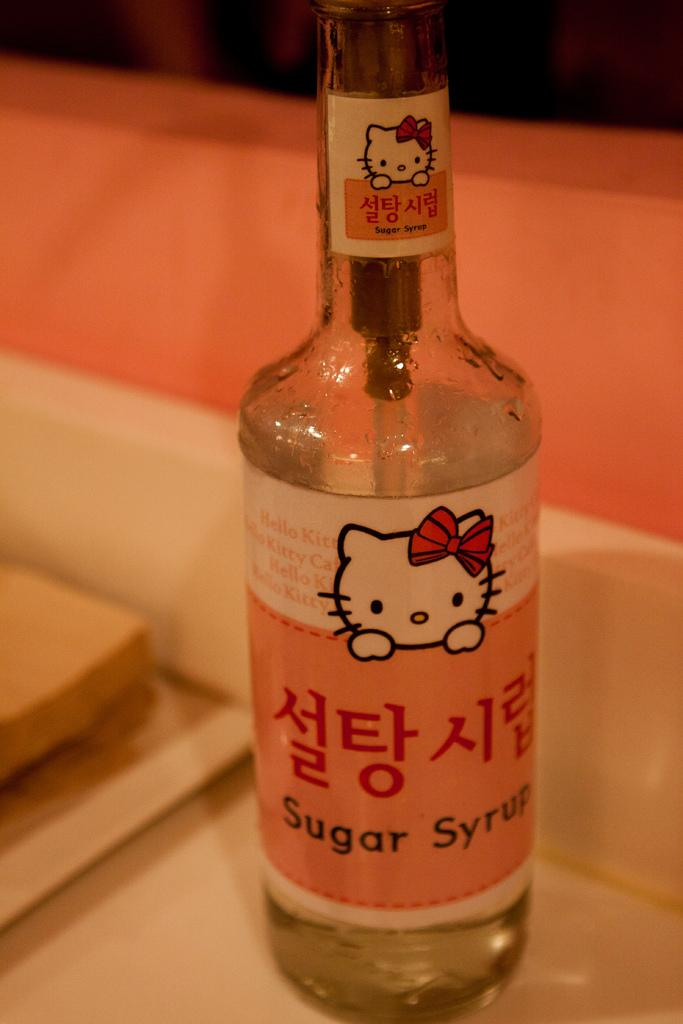What object can be seen in the image that is used for holding liquids? There is a bottle in the image that is used for holding liquids. What color is the bottle in the image? The bottle is orange in color. What piece of furniture is present in the image? There is a table in the image. What color is the table in the image? The table is white in color. What type of comfort can be found in the crib in the image? There is no crib present in the image, so it is not possible to determine what type of comfort might be found in it. 